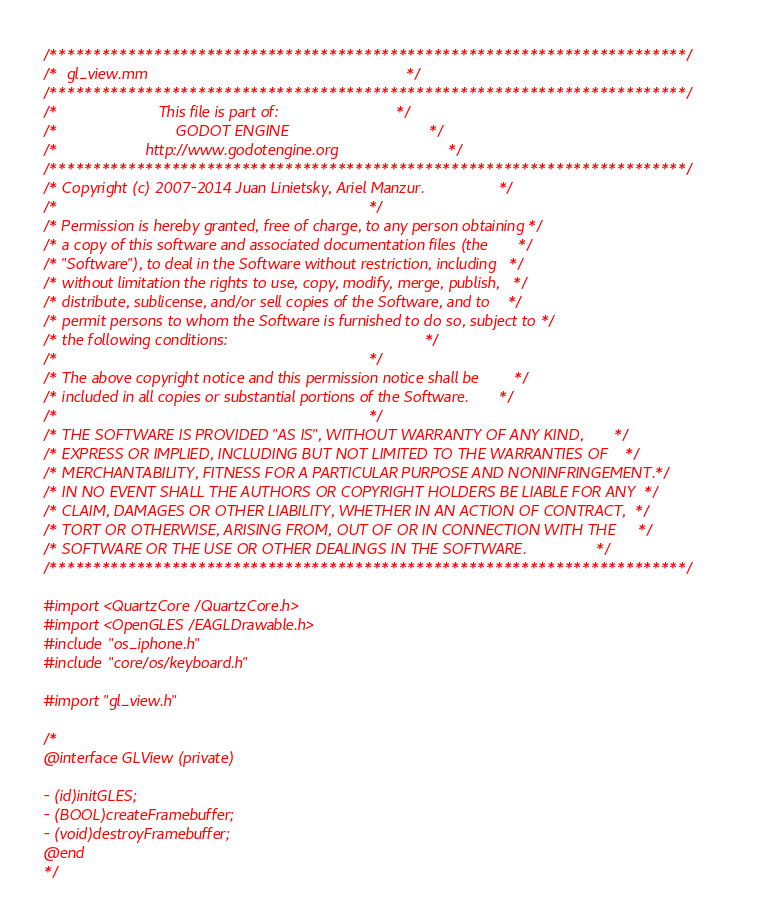Convert code to text. <code><loc_0><loc_0><loc_500><loc_500><_ObjectiveC_>/*************************************************************************/
/*  gl_view.mm                                                           */
/*************************************************************************/
/*                       This file is part of:                           */
/*                           GODOT ENGINE                                */
/*                    http://www.godotengine.org                         */
/*************************************************************************/
/* Copyright (c) 2007-2014 Juan Linietsky, Ariel Manzur.                 */
/*                                                                       */
/* Permission is hereby granted, free of charge, to any person obtaining */
/* a copy of this software and associated documentation files (the       */
/* "Software"), to deal in the Software without restriction, including   */
/* without limitation the rights to use, copy, modify, merge, publish,   */
/* distribute, sublicense, and/or sell copies of the Software, and to    */
/* permit persons to whom the Software is furnished to do so, subject to */
/* the following conditions:                                             */
/*                                                                       */
/* The above copyright notice and this permission notice shall be        */
/* included in all copies or substantial portions of the Software.       */
/*                                                                       */
/* THE SOFTWARE IS PROVIDED "AS IS", WITHOUT WARRANTY OF ANY KIND,       */
/* EXPRESS OR IMPLIED, INCLUDING BUT NOT LIMITED TO THE WARRANTIES OF    */
/* MERCHANTABILITY, FITNESS FOR A PARTICULAR PURPOSE AND NONINFRINGEMENT.*/
/* IN NO EVENT SHALL THE AUTHORS OR COPYRIGHT HOLDERS BE LIABLE FOR ANY  */
/* CLAIM, DAMAGES OR OTHER LIABILITY, WHETHER IN AN ACTION OF CONTRACT,  */
/* TORT OR OTHERWISE, ARISING FROM, OUT OF OR IN CONNECTION WITH THE     */
/* SOFTWARE OR THE USE OR OTHER DEALINGS IN THE SOFTWARE.                */
/*************************************************************************/

#import <QuartzCore/QuartzCore.h>
#import <OpenGLES/EAGLDrawable.h>
#include "os_iphone.h"
#include "core/os/keyboard.h"

#import "gl_view.h"

/*
@interface GLView (private)

- (id)initGLES;
- (BOOL)createFramebuffer;
- (void)destroyFramebuffer;
@end
*/
</code> 